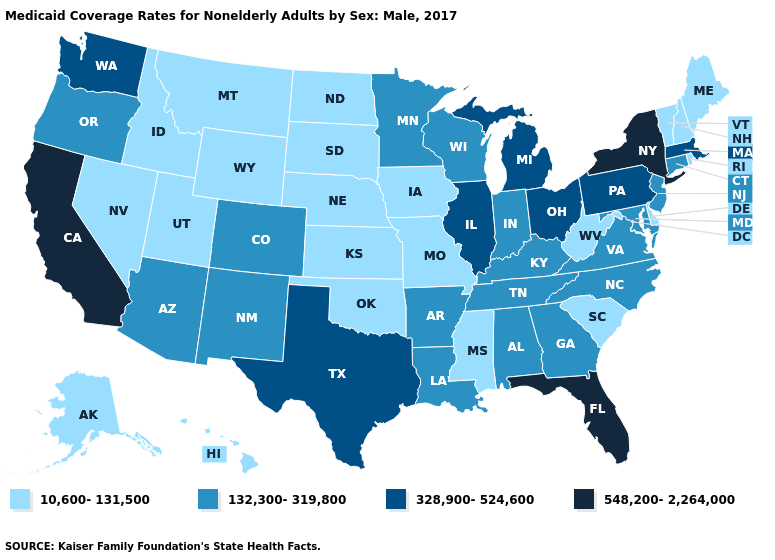Name the states that have a value in the range 132,300-319,800?
Write a very short answer. Alabama, Arizona, Arkansas, Colorado, Connecticut, Georgia, Indiana, Kentucky, Louisiana, Maryland, Minnesota, New Jersey, New Mexico, North Carolina, Oregon, Tennessee, Virginia, Wisconsin. Does Pennsylvania have the highest value in the Northeast?
Give a very brief answer. No. What is the value of Connecticut?
Answer briefly. 132,300-319,800. What is the lowest value in states that border Wisconsin?
Be succinct. 10,600-131,500. Which states have the highest value in the USA?
Quick response, please. California, Florida, New York. What is the value of Ohio?
Be succinct. 328,900-524,600. What is the value of Wyoming?
Concise answer only. 10,600-131,500. Does South Carolina have a higher value than New York?
Keep it brief. No. Among the states that border New Mexico , does Texas have the highest value?
Be succinct. Yes. Name the states that have a value in the range 328,900-524,600?
Write a very short answer. Illinois, Massachusetts, Michigan, Ohio, Pennsylvania, Texas, Washington. Name the states that have a value in the range 328,900-524,600?
Be succinct. Illinois, Massachusetts, Michigan, Ohio, Pennsylvania, Texas, Washington. What is the lowest value in states that border Nevada?
Answer briefly. 10,600-131,500. Name the states that have a value in the range 328,900-524,600?
Write a very short answer. Illinois, Massachusetts, Michigan, Ohio, Pennsylvania, Texas, Washington. What is the value of South Carolina?
Short answer required. 10,600-131,500. 